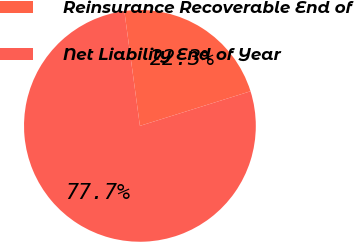Convert chart to OTSL. <chart><loc_0><loc_0><loc_500><loc_500><pie_chart><fcel>Reinsurance Recoverable End of<fcel>Net Liability End of Year<nl><fcel>22.32%<fcel>77.68%<nl></chart> 